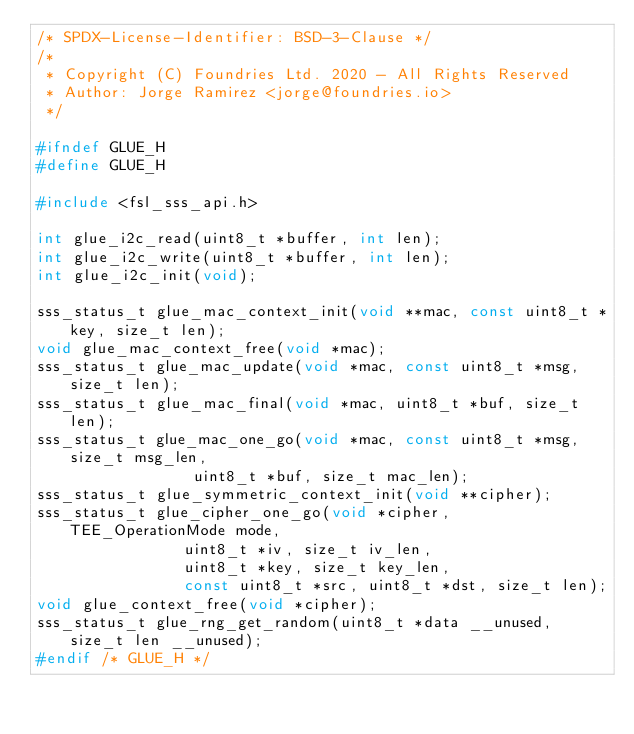<code> <loc_0><loc_0><loc_500><loc_500><_C_>/* SPDX-License-Identifier: BSD-3-Clause */
/*
 * Copyright (C) Foundries Ltd. 2020 - All Rights Reserved
 * Author: Jorge Ramirez <jorge@foundries.io>
 */

#ifndef GLUE_H
#define GLUE_H

#include <fsl_sss_api.h>

int glue_i2c_read(uint8_t *buffer, int len);
int glue_i2c_write(uint8_t *buffer, int len);
int glue_i2c_init(void);

sss_status_t glue_mac_context_init(void **mac, const uint8_t *key, size_t len);
void glue_mac_context_free(void *mac);
sss_status_t glue_mac_update(void *mac, const uint8_t *msg, size_t len);
sss_status_t glue_mac_final(void *mac, uint8_t *buf, size_t len);
sss_status_t glue_mac_one_go(void *mac, const uint8_t *msg, size_t msg_len,
			     uint8_t *buf, size_t mac_len);
sss_status_t glue_symmetric_context_init(void **cipher);
sss_status_t glue_cipher_one_go(void *cipher, TEE_OperationMode mode,
				uint8_t *iv, size_t iv_len,
				uint8_t *key, size_t key_len,
				const uint8_t *src, uint8_t *dst, size_t len);
void glue_context_free(void *cipher);
sss_status_t glue_rng_get_random(uint8_t *data __unused, size_t len __unused);
#endif /* GLUE_H */
</code> 